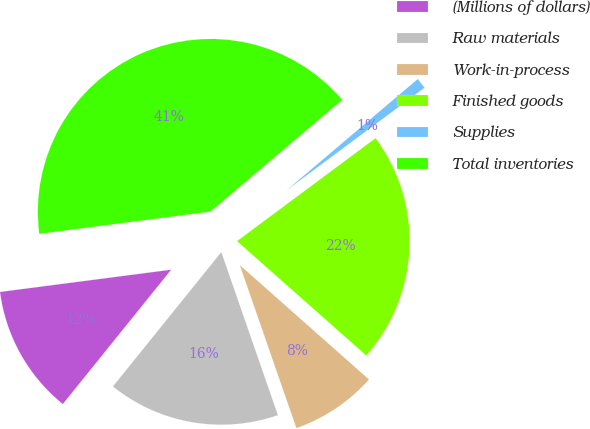Convert chart to OTSL. <chart><loc_0><loc_0><loc_500><loc_500><pie_chart><fcel>(Millions of dollars)<fcel>Raw materials<fcel>Work-in-process<fcel>Finished goods<fcel>Supplies<fcel>Total inventories<nl><fcel>12.14%<fcel>16.12%<fcel>8.15%<fcel>21.7%<fcel>1.03%<fcel>40.86%<nl></chart> 